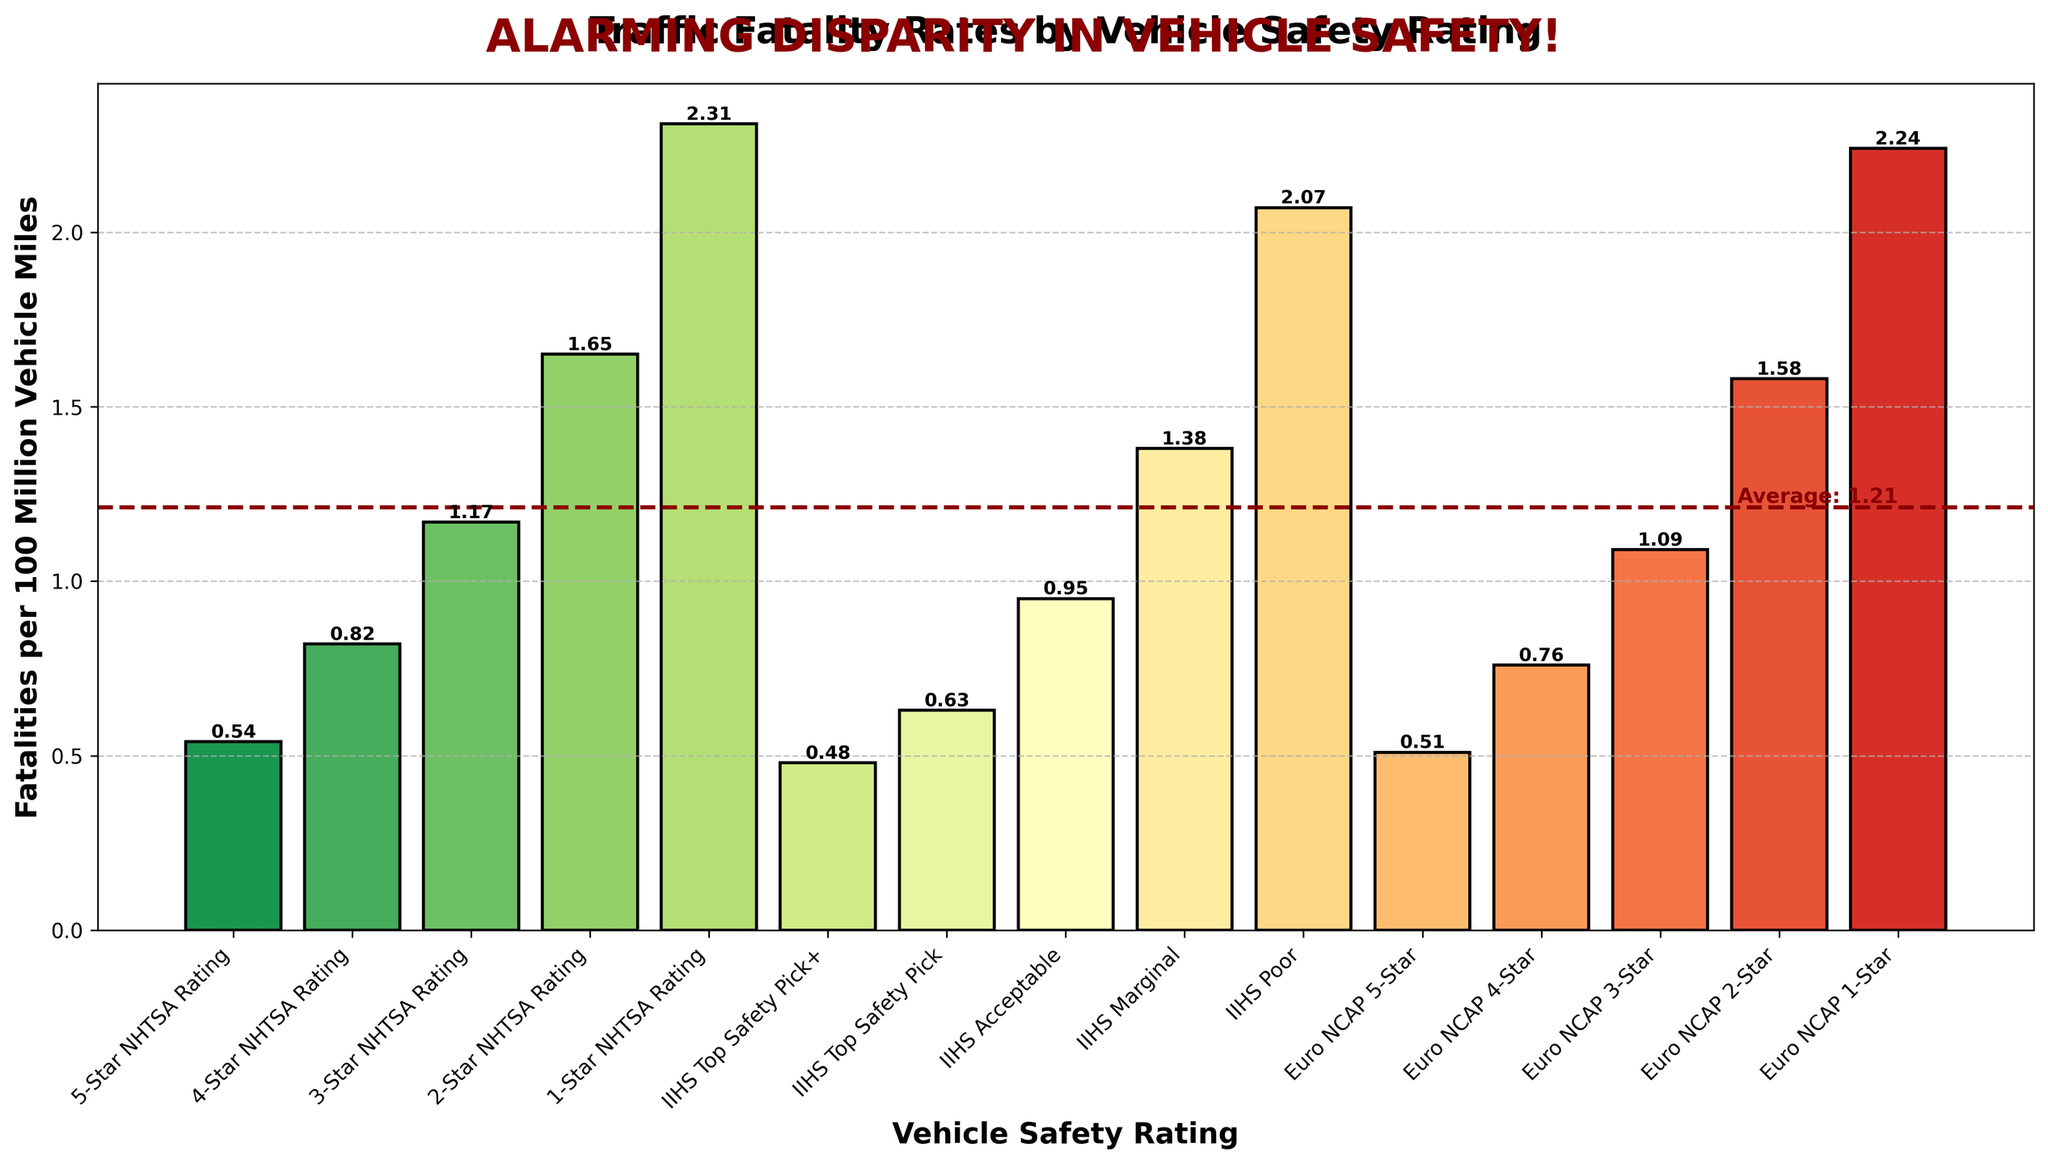What is the traffic fatality rate for vehicles with a 5-Star NHTSA rating? The bar for 5-Star NHTSA rating shows a height representing the fatality rate of 0.54 per 100 million vehicle miles.
Answer: 0.54 Which vehicle safety rating has the highest traffic fatality rate? The bar for the 1-Star NHTSA rating has the highest height, representing a fatality rate of 2.31 per 100 million vehicle miles.
Answer: 1-Star NHTSA Rating How does the fatality rate of IIHS Top Safety Pick compare to the fatality rate of IIHS Poor? The IIHS Top Safety Pick has a fatality rate of 0.63 per 100 million vehicle miles, while IIHS Poor has a fatality rate of 2.07 per 100 million vehicle miles. The IIHS Poor rating has a much higher fatality rate.
Answer: IIHS Poor has a much higher fatality rate What is the average fatality rate highlighted by the horizontal line? The horizontal line drawn across the bars represents the average fatality rate, marked with a value of 1.10 per 100 million vehicle miles.
Answer: 1.10 Identify the safety rating with the lowest fatality rate and its corresponding value. The lowest fatality rate is for the IIHS Top Safety Pick+ with a value of 0.48 per 100 million vehicle miles, as indicated by the shortest bar.
Answer: IIHS Top Safety Pick+, 0.48 What is the difference in fatality rates between a 2-Star NHTSA rating and a Euro NCAP 3-Star rating? The fatality rate for a 2-Star NHTSA rating is 1.65, and for a Euro NCAP 3-Star rating, it is 1.09. The difference is calculated as 1.65 - 1.09 = 0.56.
Answer: 0.56 Compare the fatality rates of vehicles with a Euro NCAP 5-Star rating and a Euro NCAP 2-Star rating. Euro NCAP 5-Star has a fatality rate of 0.51, and Euro NCAP 2-Star has a rate of 1.58, indicating that 2-Star rated vehicles have a much higher fatality rate.
Answer: Euro NCAP 2-Star has a much higher rate Among the IIHS ratings, which has the closest fatality rate to the overall average fatality rate? The overall average fatality rate is 1.10, and among the IIHS ratings, the IIHS Acceptable rating has a fatality rate of 0.95, which is the closest to the average.
Answer: IIHS Acceptable How much greater is the fatality rate for vehicles with a 1-Star NHTSA rating compared to a 4-Star NHTSA rating? The fatality rate for a 1-Star NHTSA rating is 2.31, and for a 4-Star rating, it is 0.82. The calculation is 2.31 - 0.82 = 1.49.
Answer: 1.49 